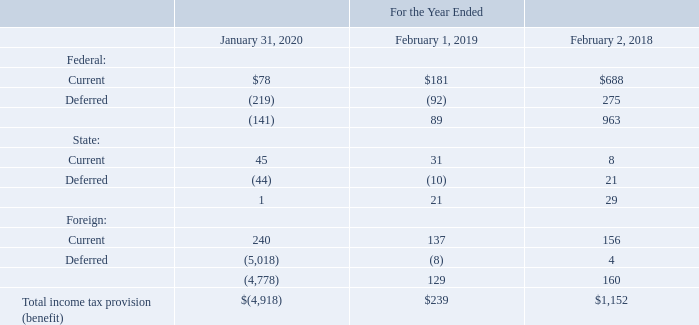P. Income Taxes
VMware’s income tax provision (benefit) for the periods presented consisted of the following (table in millions):
Which years does the table provide information for VMware’s income tax provision (benefit)? 2020, 2019, 2018. What was the current federal income tax provision in 2019?
Answer scale should be: million. 181. What was the current state income tax provision in 2020?
Answer scale should be: million. 45. What was the change in the current federal income tax provision between 2018 and 2019?
Answer scale should be: million. 181-688
Answer: -507. How many years did current foreign income tax provision exceed $200 million? 2020
Answer: 1. What was the percentage change in the Total income tax provision between 2018 and 2019?
Answer scale should be: percent. (239-1,152)/1,152
Answer: -79.25. 